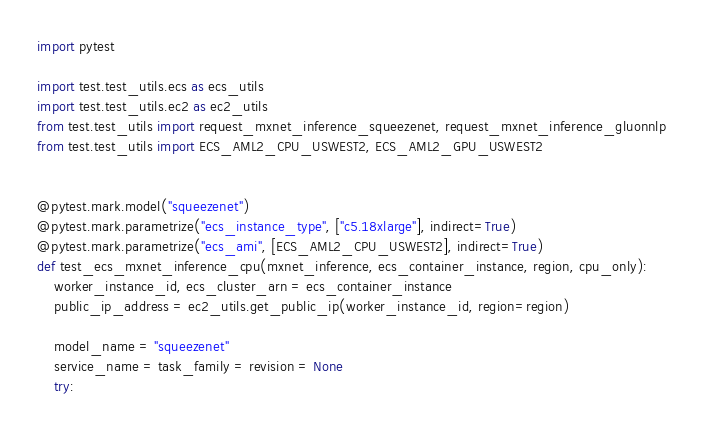<code> <loc_0><loc_0><loc_500><loc_500><_Python_>import pytest

import test.test_utils.ecs as ecs_utils
import test.test_utils.ec2 as ec2_utils
from test.test_utils import request_mxnet_inference_squeezenet, request_mxnet_inference_gluonnlp
from test.test_utils import ECS_AML2_CPU_USWEST2, ECS_AML2_GPU_USWEST2


@pytest.mark.model("squeezenet")
@pytest.mark.parametrize("ecs_instance_type", ["c5.18xlarge"], indirect=True)
@pytest.mark.parametrize("ecs_ami", [ECS_AML2_CPU_USWEST2], indirect=True)
def test_ecs_mxnet_inference_cpu(mxnet_inference, ecs_container_instance, region, cpu_only):
    worker_instance_id, ecs_cluster_arn = ecs_container_instance
    public_ip_address = ec2_utils.get_public_ip(worker_instance_id, region=region)

    model_name = "squeezenet"
    service_name = task_family = revision = None
    try:</code> 